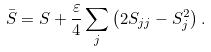<formula> <loc_0><loc_0><loc_500><loc_500>\bar { S } = S + \frac { \varepsilon } { 4 } \sum _ { j } \left ( 2 S _ { j j } - S _ { j } ^ { 2 } \right ) .</formula> 